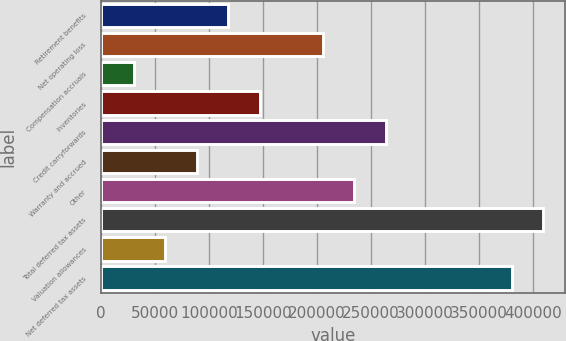<chart> <loc_0><loc_0><loc_500><loc_500><bar_chart><fcel>Retirement benefits<fcel>Net operating loss<fcel>Compensation accruals<fcel>Inventories<fcel>Credit carryforwards<fcel>Warranty and accrued<fcel>Other<fcel>Total deferred tax assets<fcel>Valuation allowances<fcel>Net deferred tax assets<nl><fcel>117853<fcel>205407<fcel>30299<fcel>147037<fcel>263776<fcel>88668.2<fcel>234591<fcel>409699<fcel>59483.6<fcel>380514<nl></chart> 